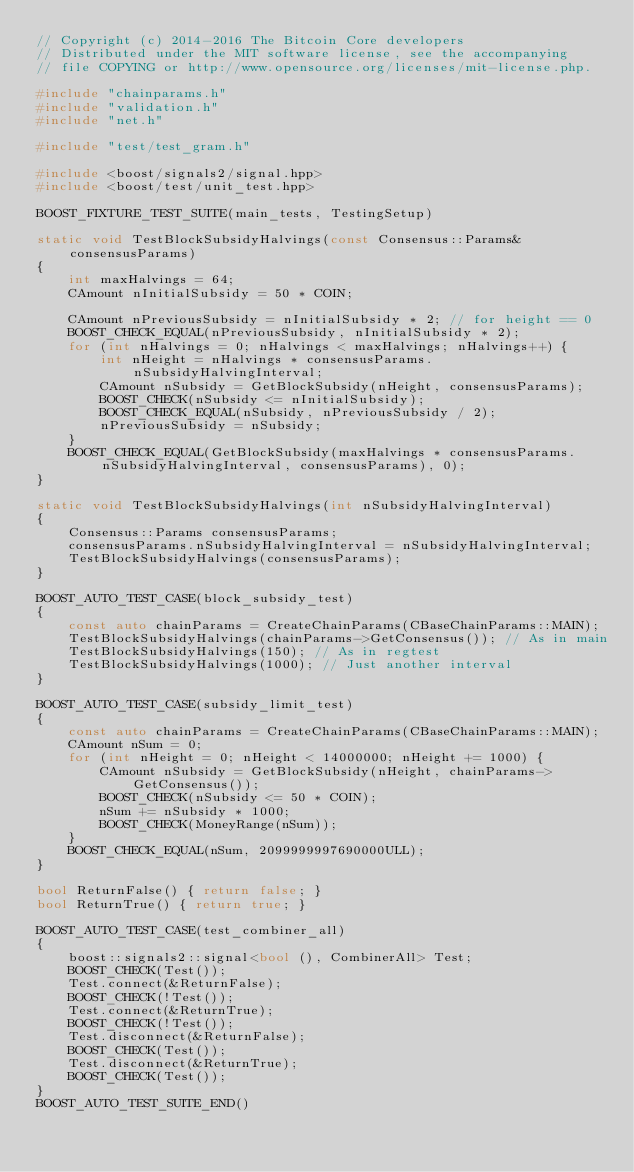Convert code to text. <code><loc_0><loc_0><loc_500><loc_500><_C++_>// Copyright (c) 2014-2016 The Bitcoin Core developers
// Distributed under the MIT software license, see the accompanying
// file COPYING or http://www.opensource.org/licenses/mit-license.php.

#include "chainparams.h"
#include "validation.h"
#include "net.h"

#include "test/test_gram.h"

#include <boost/signals2/signal.hpp>
#include <boost/test/unit_test.hpp>

BOOST_FIXTURE_TEST_SUITE(main_tests, TestingSetup)

static void TestBlockSubsidyHalvings(const Consensus::Params& consensusParams)
{
    int maxHalvings = 64;
    CAmount nInitialSubsidy = 50 * COIN;

    CAmount nPreviousSubsidy = nInitialSubsidy * 2; // for height == 0
    BOOST_CHECK_EQUAL(nPreviousSubsidy, nInitialSubsidy * 2);
    for (int nHalvings = 0; nHalvings < maxHalvings; nHalvings++) {
        int nHeight = nHalvings * consensusParams.nSubsidyHalvingInterval;
        CAmount nSubsidy = GetBlockSubsidy(nHeight, consensusParams);
        BOOST_CHECK(nSubsidy <= nInitialSubsidy);
        BOOST_CHECK_EQUAL(nSubsidy, nPreviousSubsidy / 2);
        nPreviousSubsidy = nSubsidy;
    }
    BOOST_CHECK_EQUAL(GetBlockSubsidy(maxHalvings * consensusParams.nSubsidyHalvingInterval, consensusParams), 0);
}

static void TestBlockSubsidyHalvings(int nSubsidyHalvingInterval)
{
    Consensus::Params consensusParams;
    consensusParams.nSubsidyHalvingInterval = nSubsidyHalvingInterval;
    TestBlockSubsidyHalvings(consensusParams);
}

BOOST_AUTO_TEST_CASE(block_subsidy_test)
{
    const auto chainParams = CreateChainParams(CBaseChainParams::MAIN);
    TestBlockSubsidyHalvings(chainParams->GetConsensus()); // As in main
    TestBlockSubsidyHalvings(150); // As in regtest
    TestBlockSubsidyHalvings(1000); // Just another interval
}

BOOST_AUTO_TEST_CASE(subsidy_limit_test)
{
    const auto chainParams = CreateChainParams(CBaseChainParams::MAIN);
    CAmount nSum = 0;
    for (int nHeight = 0; nHeight < 14000000; nHeight += 1000) {
        CAmount nSubsidy = GetBlockSubsidy(nHeight, chainParams->GetConsensus());
        BOOST_CHECK(nSubsidy <= 50 * COIN);
        nSum += nSubsidy * 1000;
        BOOST_CHECK(MoneyRange(nSum));
    }
    BOOST_CHECK_EQUAL(nSum, 2099999997690000ULL);
}

bool ReturnFalse() { return false; }
bool ReturnTrue() { return true; }

BOOST_AUTO_TEST_CASE(test_combiner_all)
{
    boost::signals2::signal<bool (), CombinerAll> Test;
    BOOST_CHECK(Test());
    Test.connect(&ReturnFalse);
    BOOST_CHECK(!Test());
    Test.connect(&ReturnTrue);
    BOOST_CHECK(!Test());
    Test.disconnect(&ReturnFalse);
    BOOST_CHECK(Test());
    Test.disconnect(&ReturnTrue);
    BOOST_CHECK(Test());
}
BOOST_AUTO_TEST_SUITE_END()
</code> 